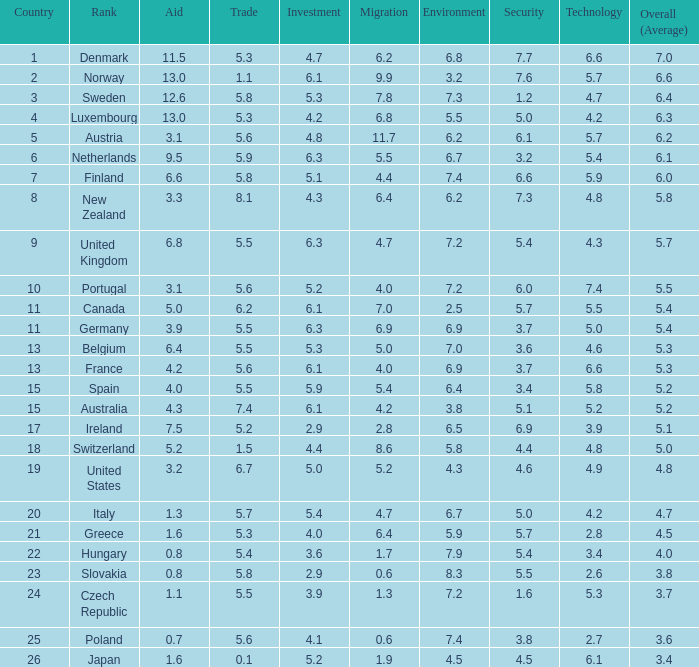7? 4.7. 